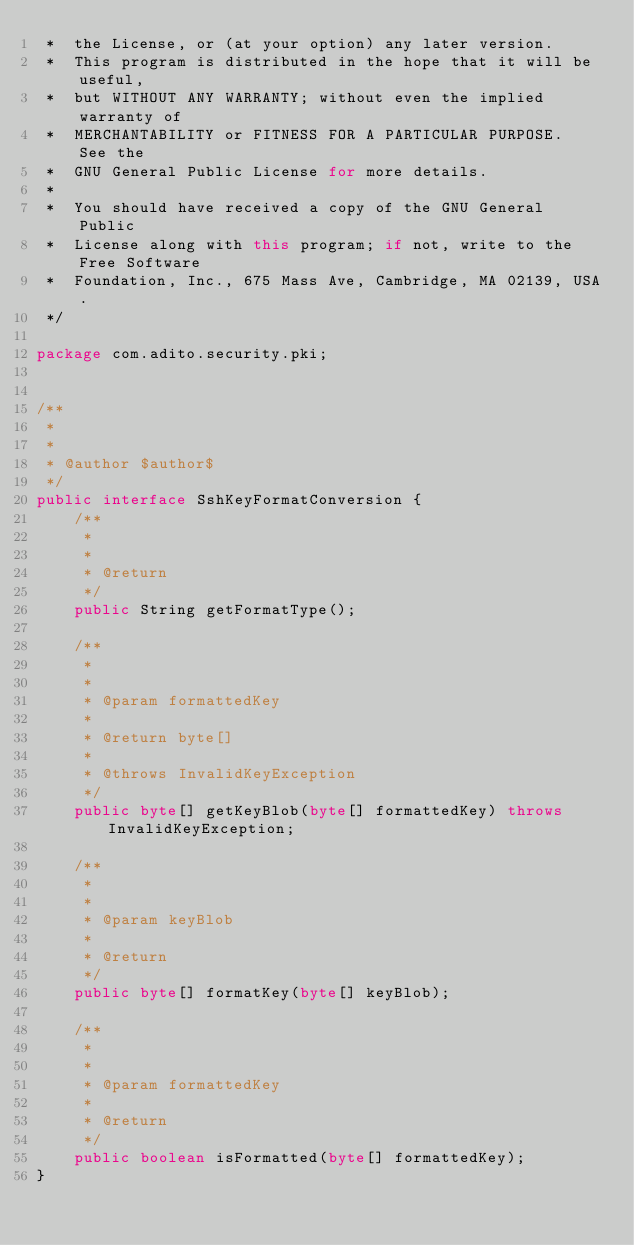<code> <loc_0><loc_0><loc_500><loc_500><_Java_> *  the License, or (at your option) any later version.
 *  This program is distributed in the hope that it will be useful,
 *  but WITHOUT ANY WARRANTY; without even the implied warranty of
 *  MERCHANTABILITY or FITNESS FOR A PARTICULAR PURPOSE.  See the
 *  GNU General Public License for more details.
 *
 *  You should have received a copy of the GNU General Public
 *  License along with this program; if not, write to the Free Software
 *  Foundation, Inc., 675 Mass Ave, Cambridge, MA 02139, USA.
 */
			
package com.adito.security.pki;


/**
 *
 *
 * @author $author$
 */
public interface SshKeyFormatConversion {
    /**
     *
     *
     * @return
     */
    public String getFormatType();

    /**
     *
     *
     * @param formattedKey
     *
     * @return byte[]
     *
     * @throws InvalidKeyException
     */
    public byte[] getKeyBlob(byte[] formattedKey) throws InvalidKeyException;

    /**
     *
     *
     * @param keyBlob
     *
     * @return
     */
    public byte[] formatKey(byte[] keyBlob);

    /**
     *
     *
     * @param formattedKey
     *
     * @return
     */
    public boolean isFormatted(byte[] formattedKey);
}
</code> 